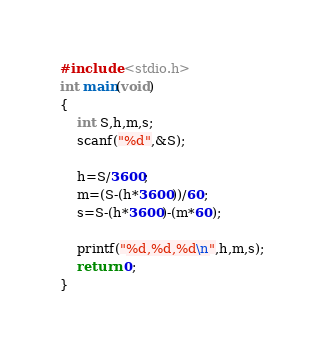<code> <loc_0><loc_0><loc_500><loc_500><_C_>#include <stdio.h>
int main(void)
{
	int S,h,m,s;
	scanf("%d",&S);
	
	h=S/3600;
	m=(S-(h*3600))/60;
	s=S-(h*3600)-(m*60);
	
	printf("%d,%d,%d\n",h,m,s);
	return 0;
}</code> 